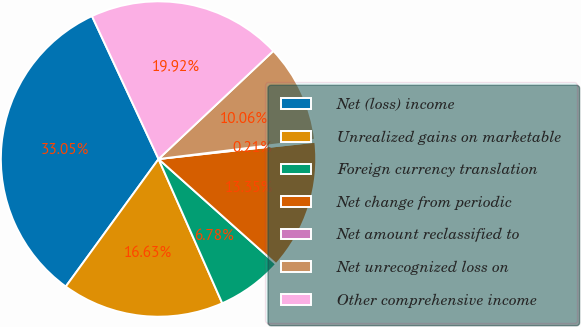Convert chart to OTSL. <chart><loc_0><loc_0><loc_500><loc_500><pie_chart><fcel>Net (loss) income<fcel>Unrealized gains on marketable<fcel>Foreign currency translation<fcel>Net change from periodic<fcel>Net amount reclassified to<fcel>Net unrecognized loss on<fcel>Other comprehensive income<nl><fcel>33.05%<fcel>16.63%<fcel>6.78%<fcel>13.35%<fcel>0.21%<fcel>10.06%<fcel>19.92%<nl></chart> 